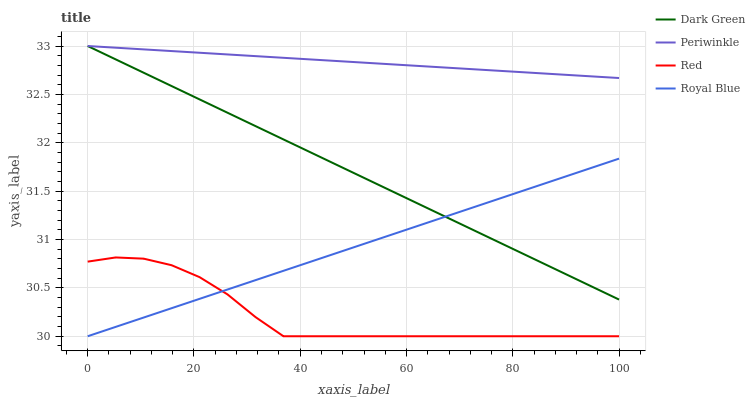Does Red have the minimum area under the curve?
Answer yes or no. Yes. Does Periwinkle have the maximum area under the curve?
Answer yes or no. Yes. Does Periwinkle have the minimum area under the curve?
Answer yes or no. No. Does Red have the maximum area under the curve?
Answer yes or no. No. Is Dark Green the smoothest?
Answer yes or no. Yes. Is Red the roughest?
Answer yes or no. Yes. Is Periwinkle the smoothest?
Answer yes or no. No. Is Periwinkle the roughest?
Answer yes or no. No. Does Royal Blue have the lowest value?
Answer yes or no. Yes. Does Periwinkle have the lowest value?
Answer yes or no. No. Does Dark Green have the highest value?
Answer yes or no. Yes. Does Red have the highest value?
Answer yes or no. No. Is Red less than Dark Green?
Answer yes or no. Yes. Is Periwinkle greater than Red?
Answer yes or no. Yes. Does Royal Blue intersect Dark Green?
Answer yes or no. Yes. Is Royal Blue less than Dark Green?
Answer yes or no. No. Is Royal Blue greater than Dark Green?
Answer yes or no. No. Does Red intersect Dark Green?
Answer yes or no. No. 